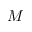Convert formula to latex. <formula><loc_0><loc_0><loc_500><loc_500>M</formula> 